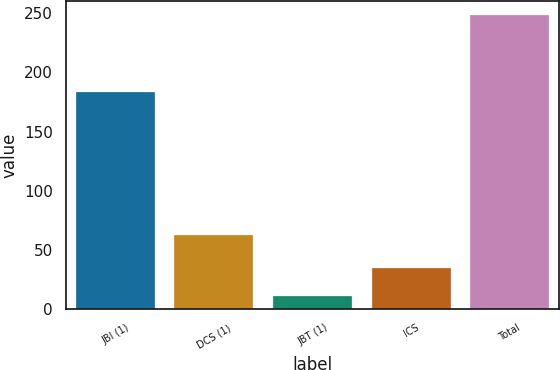Convert chart to OTSL. <chart><loc_0><loc_0><loc_500><loc_500><bar_chart><fcel>JBI (1)<fcel>DCS (1)<fcel>JBT (1)<fcel>ICS<fcel>Total<nl><fcel>183<fcel>63<fcel>11<fcel>34.7<fcel>248<nl></chart> 